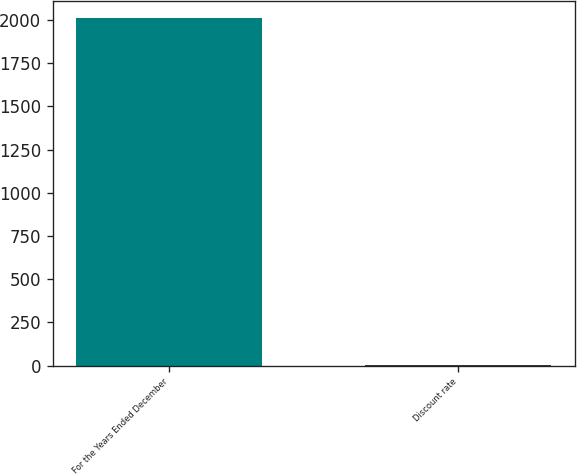Convert chart to OTSL. <chart><loc_0><loc_0><loc_500><loc_500><bar_chart><fcel>For the Years Ended December<fcel>Discount rate<nl><fcel>2011<fcel>2.49<nl></chart> 